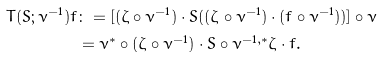Convert formula to latex. <formula><loc_0><loc_0><loc_500><loc_500>T ( S ; \nu ^ { - 1 } ) f & \colon = [ ( \zeta \circ \nu ^ { - 1 } ) \cdot S ( ( \zeta \circ \nu ^ { - 1 } ) \cdot ( f \circ \nu ^ { - 1 } ) ) ] \circ \nu \\ & = \nu ^ { * } \circ ( \zeta \circ \nu ^ { - 1 } ) \cdot S \circ \nu ^ { - 1 , * } \zeta \cdot f .</formula> 